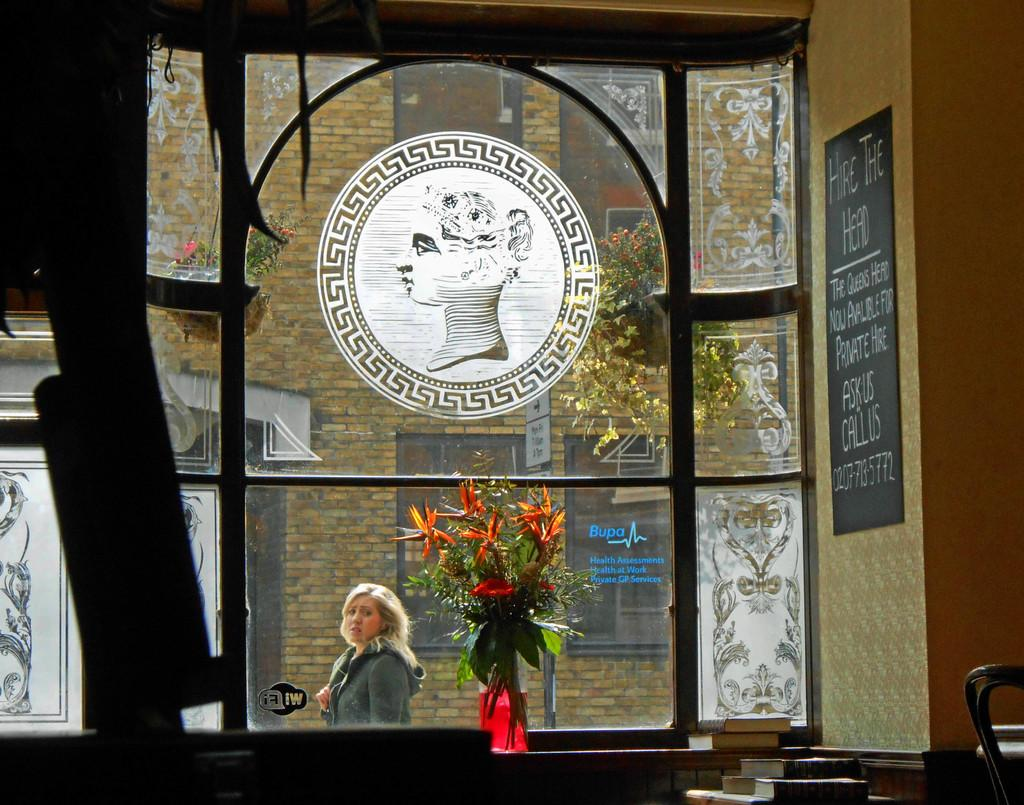<image>
Describe the image concisely. a shop interior looking out a window has a board reads Hire the Head 